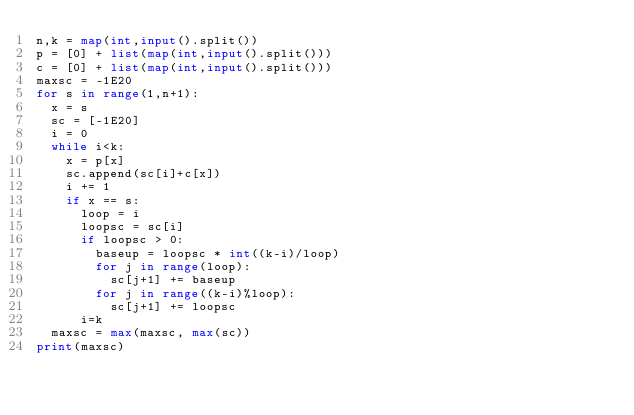Convert code to text. <code><loc_0><loc_0><loc_500><loc_500><_Python_>n,k = map(int,input().split())
p = [0] + list(map(int,input().split()))
c = [0] + list(map(int,input().split()))
maxsc = -1E20
for s in range(1,n+1):
  x = s
  sc = [-1E20]
  i = 0
  while i<k:
    x = p[x]
    sc.append(sc[i]+c[x])
    i += 1
    if x == s:
      loop = i
      loopsc = sc[i]
      if loopsc > 0:
        baseup = loopsc * int((k-i)/loop)
        for j in range(loop):
          sc[j+1] += baseup
        for j in range((k-i)%loop):
          sc[j+1] += loopsc
      i=k
  maxsc = max(maxsc, max(sc))
print(maxsc)
    
</code> 